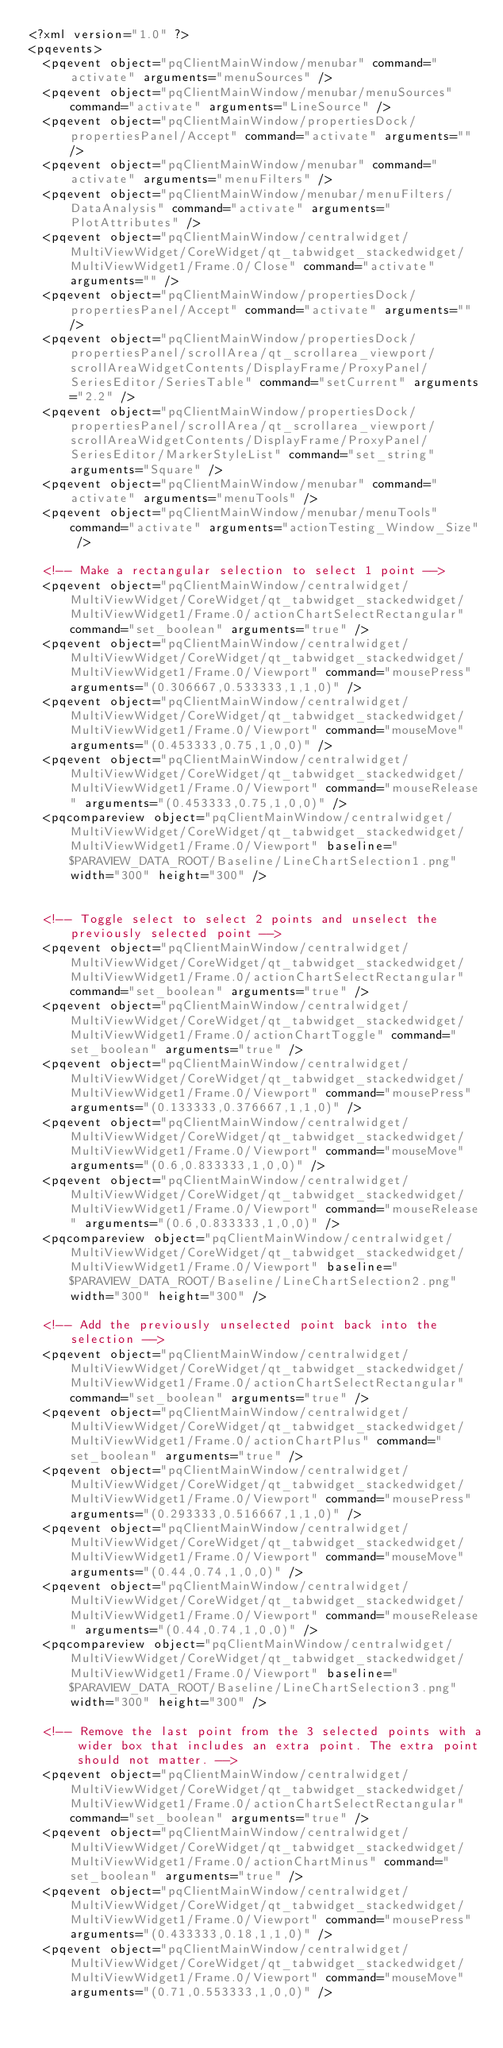Convert code to text. <code><loc_0><loc_0><loc_500><loc_500><_XML_><?xml version="1.0" ?>
<pqevents>
  <pqevent object="pqClientMainWindow/menubar" command="activate" arguments="menuSources" />
  <pqevent object="pqClientMainWindow/menubar/menuSources" command="activate" arguments="LineSource" />
  <pqevent object="pqClientMainWindow/propertiesDock/propertiesPanel/Accept" command="activate" arguments="" />
  <pqevent object="pqClientMainWindow/menubar" command="activate" arguments="menuFilters" />
  <pqevent object="pqClientMainWindow/menubar/menuFilters/DataAnalysis" command="activate" arguments="PlotAttributes" />
  <pqevent object="pqClientMainWindow/centralwidget/MultiViewWidget/CoreWidget/qt_tabwidget_stackedwidget/MultiViewWidget1/Frame.0/Close" command="activate" arguments="" />
  <pqevent object="pqClientMainWindow/propertiesDock/propertiesPanel/Accept" command="activate" arguments="" />
  <pqevent object="pqClientMainWindow/propertiesDock/propertiesPanel/scrollArea/qt_scrollarea_viewport/scrollAreaWidgetContents/DisplayFrame/ProxyPanel/SeriesEditor/SeriesTable" command="setCurrent" arguments="2.2" />
  <pqevent object="pqClientMainWindow/propertiesDock/propertiesPanel/scrollArea/qt_scrollarea_viewport/scrollAreaWidgetContents/DisplayFrame/ProxyPanel/SeriesEditor/MarkerStyleList" command="set_string" arguments="Square" />
  <pqevent object="pqClientMainWindow/menubar" command="activate" arguments="menuTools" />
  <pqevent object="pqClientMainWindow/menubar/menuTools" command="activate" arguments="actionTesting_Window_Size" />

  <!-- Make a rectangular selection to select 1 point -->
  <pqevent object="pqClientMainWindow/centralwidget/MultiViewWidget/CoreWidget/qt_tabwidget_stackedwidget/MultiViewWidget1/Frame.0/actionChartSelectRectangular" command="set_boolean" arguments="true" />
  <pqevent object="pqClientMainWindow/centralwidget/MultiViewWidget/CoreWidget/qt_tabwidget_stackedwidget/MultiViewWidget1/Frame.0/Viewport" command="mousePress" arguments="(0.306667,0.533333,1,1,0)" />
  <pqevent object="pqClientMainWindow/centralwidget/MultiViewWidget/CoreWidget/qt_tabwidget_stackedwidget/MultiViewWidget1/Frame.0/Viewport" command="mouseMove" arguments="(0.453333,0.75,1,0,0)" />
  <pqevent object="pqClientMainWindow/centralwidget/MultiViewWidget/CoreWidget/qt_tabwidget_stackedwidget/MultiViewWidget1/Frame.0/Viewport" command="mouseRelease" arguments="(0.453333,0.75,1,0,0)" />
  <pqcompareview object="pqClientMainWindow/centralwidget/MultiViewWidget/CoreWidget/qt_tabwidget_stackedwidget/MultiViewWidget1/Frame.0/Viewport" baseline="$PARAVIEW_DATA_ROOT/Baseline/LineChartSelection1.png" width="300" height="300" />


  <!-- Toggle select to select 2 points and unselect the previously selected point -->
  <pqevent object="pqClientMainWindow/centralwidget/MultiViewWidget/CoreWidget/qt_tabwidget_stackedwidget/MultiViewWidget1/Frame.0/actionChartSelectRectangular" command="set_boolean" arguments="true" />
  <pqevent object="pqClientMainWindow/centralwidget/MultiViewWidget/CoreWidget/qt_tabwidget_stackedwidget/MultiViewWidget1/Frame.0/actionChartToggle" command="set_boolean" arguments="true" />
  <pqevent object="pqClientMainWindow/centralwidget/MultiViewWidget/CoreWidget/qt_tabwidget_stackedwidget/MultiViewWidget1/Frame.0/Viewport" command="mousePress" arguments="(0.133333,0.376667,1,1,0)" />
  <pqevent object="pqClientMainWindow/centralwidget/MultiViewWidget/CoreWidget/qt_tabwidget_stackedwidget/MultiViewWidget1/Frame.0/Viewport" command="mouseMove" arguments="(0.6,0.833333,1,0,0)" />
  <pqevent object="pqClientMainWindow/centralwidget/MultiViewWidget/CoreWidget/qt_tabwidget_stackedwidget/MultiViewWidget1/Frame.0/Viewport" command="mouseRelease" arguments="(0.6,0.833333,1,0,0)" />
  <pqcompareview object="pqClientMainWindow/centralwidget/MultiViewWidget/CoreWidget/qt_tabwidget_stackedwidget/MultiViewWidget1/Frame.0/Viewport" baseline="$PARAVIEW_DATA_ROOT/Baseline/LineChartSelection2.png" width="300" height="300" />

  <!-- Add the previously unselected point back into the selection -->
  <pqevent object="pqClientMainWindow/centralwidget/MultiViewWidget/CoreWidget/qt_tabwidget_stackedwidget/MultiViewWidget1/Frame.0/actionChartSelectRectangular" command="set_boolean" arguments="true" />
  <pqevent object="pqClientMainWindow/centralwidget/MultiViewWidget/CoreWidget/qt_tabwidget_stackedwidget/MultiViewWidget1/Frame.0/actionChartPlus" command="set_boolean" arguments="true" />
  <pqevent object="pqClientMainWindow/centralwidget/MultiViewWidget/CoreWidget/qt_tabwidget_stackedwidget/MultiViewWidget1/Frame.0/Viewport" command="mousePress" arguments="(0.293333,0.516667,1,1,0)" />
  <pqevent object="pqClientMainWindow/centralwidget/MultiViewWidget/CoreWidget/qt_tabwidget_stackedwidget/MultiViewWidget1/Frame.0/Viewport" command="mouseMove" arguments="(0.44,0.74,1,0,0)" />
  <pqevent object="pqClientMainWindow/centralwidget/MultiViewWidget/CoreWidget/qt_tabwidget_stackedwidget/MultiViewWidget1/Frame.0/Viewport" command="mouseRelease" arguments="(0.44,0.74,1,0,0)" />
  <pqcompareview object="pqClientMainWindow/centralwidget/MultiViewWidget/CoreWidget/qt_tabwidget_stackedwidget/MultiViewWidget1/Frame.0/Viewport" baseline="$PARAVIEW_DATA_ROOT/Baseline/LineChartSelection3.png" width="300" height="300" />

  <!-- Remove the last point from the 3 selected points with a wider box that includes an extra point. The extra point should not matter. -->
  <pqevent object="pqClientMainWindow/centralwidget/MultiViewWidget/CoreWidget/qt_tabwidget_stackedwidget/MultiViewWidget1/Frame.0/actionChartSelectRectangular" command="set_boolean" arguments="true" />
  <pqevent object="pqClientMainWindow/centralwidget/MultiViewWidget/CoreWidget/qt_tabwidget_stackedwidget/MultiViewWidget1/Frame.0/actionChartMinus" command="set_boolean" arguments="true" />
  <pqevent object="pqClientMainWindow/centralwidget/MultiViewWidget/CoreWidget/qt_tabwidget_stackedwidget/MultiViewWidget1/Frame.0/Viewport" command="mousePress" arguments="(0.433333,0.18,1,1,0)" />
  <pqevent object="pqClientMainWindow/centralwidget/MultiViewWidget/CoreWidget/qt_tabwidget_stackedwidget/MultiViewWidget1/Frame.0/Viewport" command="mouseMove" arguments="(0.71,0.553333,1,0,0)" /></code> 